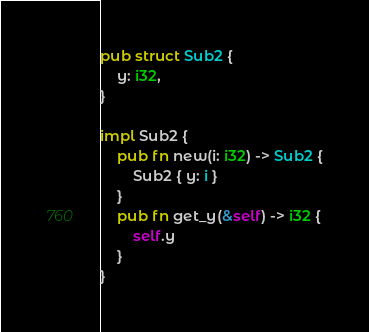Convert code to text. <code><loc_0><loc_0><loc_500><loc_500><_Rust_>pub struct Sub2 {
    y: i32,
}

impl Sub2 {
    pub fn new(i: i32) -> Sub2 {
        Sub2 { y: i }
    }
    pub fn get_y(&self) -> i32 {
        self.y
    }
}
</code> 